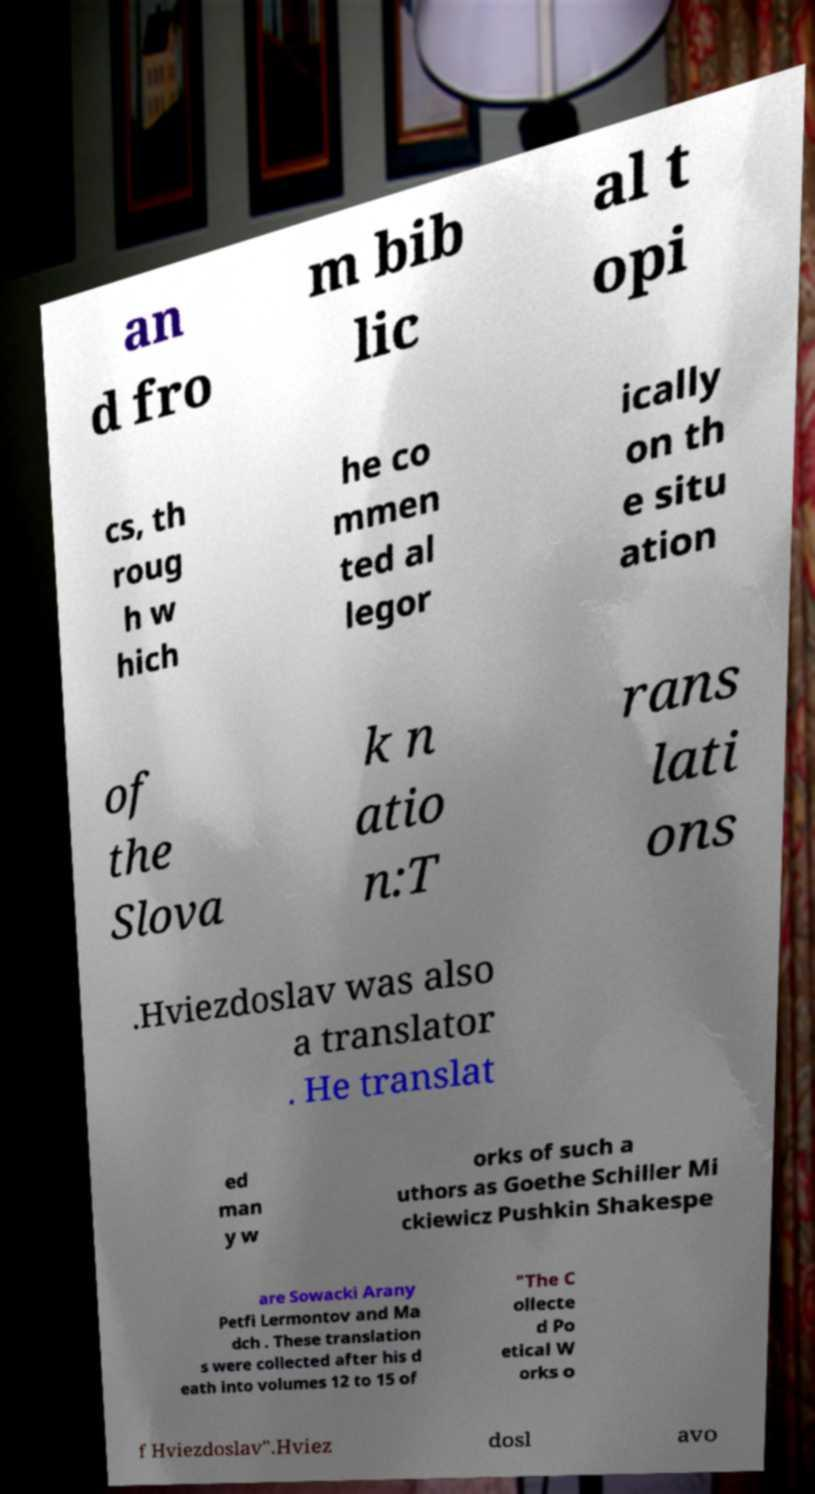Could you assist in decoding the text presented in this image and type it out clearly? an d fro m bib lic al t opi cs, th roug h w hich he co mmen ted al legor ically on th e situ ation of the Slova k n atio n:T rans lati ons .Hviezdoslav was also a translator . He translat ed man y w orks of such a uthors as Goethe Schiller Mi ckiewicz Pushkin Shakespe are Sowacki Arany Petfi Lermontov and Ma dch . These translation s were collected after his d eath into volumes 12 to 15 of "The C ollecte d Po etical W orks o f Hviezdoslav".Hviez dosl avo 